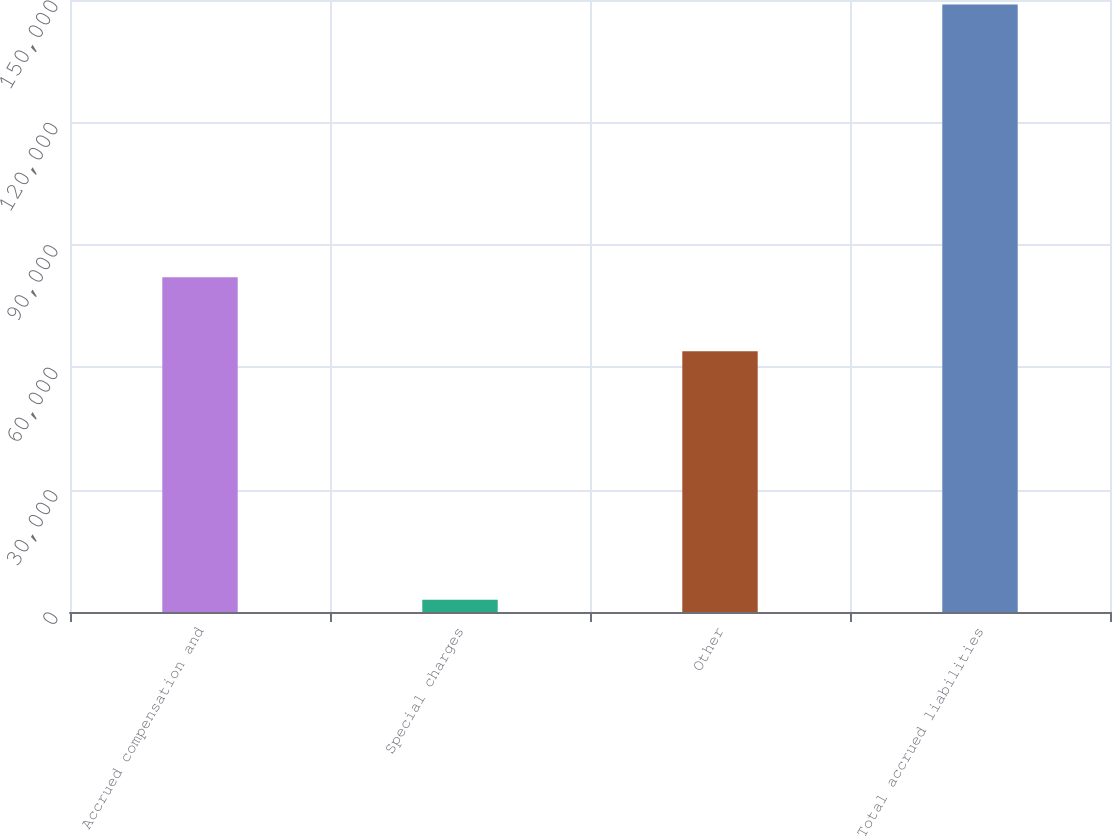Convert chart. <chart><loc_0><loc_0><loc_500><loc_500><bar_chart><fcel>Accrued compensation and<fcel>Special charges<fcel>Other<fcel>Total accrued liabilities<nl><fcel>82027<fcel>2993<fcel>63887<fcel>148907<nl></chart> 